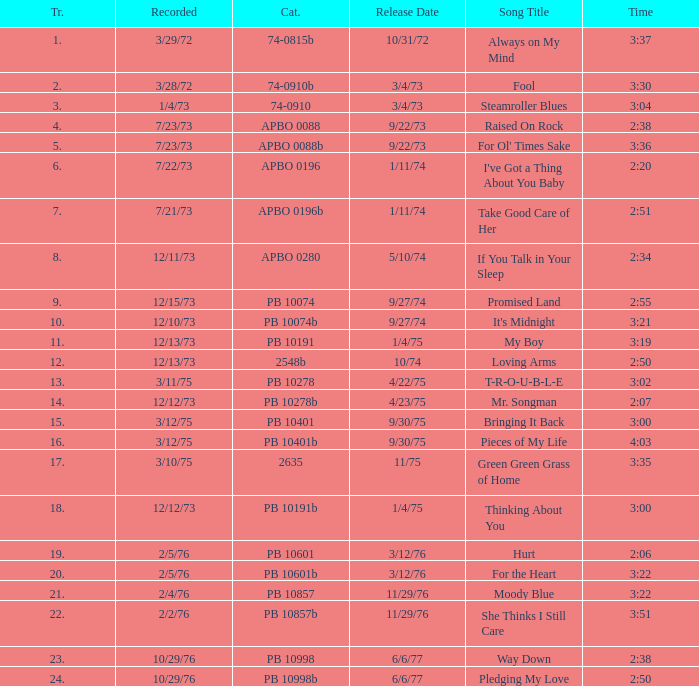Name the catalogue that has tracks less than 13 and the release date of 10/31/72 74-0815b. 